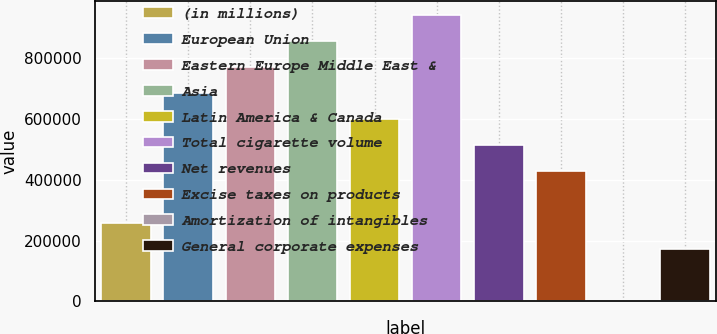Convert chart. <chart><loc_0><loc_0><loc_500><loc_500><bar_chart><fcel>(in millions)<fcel>European Union<fcel>Eastern Europe Middle East &<fcel>Asia<fcel>Latin America & Canada<fcel>Total cigarette volume<fcel>Net revenues<fcel>Excise taxes on products<fcel>Amortization of intangibles<fcel>General corporate expenses<nl><fcel>256851<fcel>684782<fcel>770368<fcel>855954<fcel>599196<fcel>941540<fcel>513610<fcel>428024<fcel>93<fcel>171265<nl></chart> 